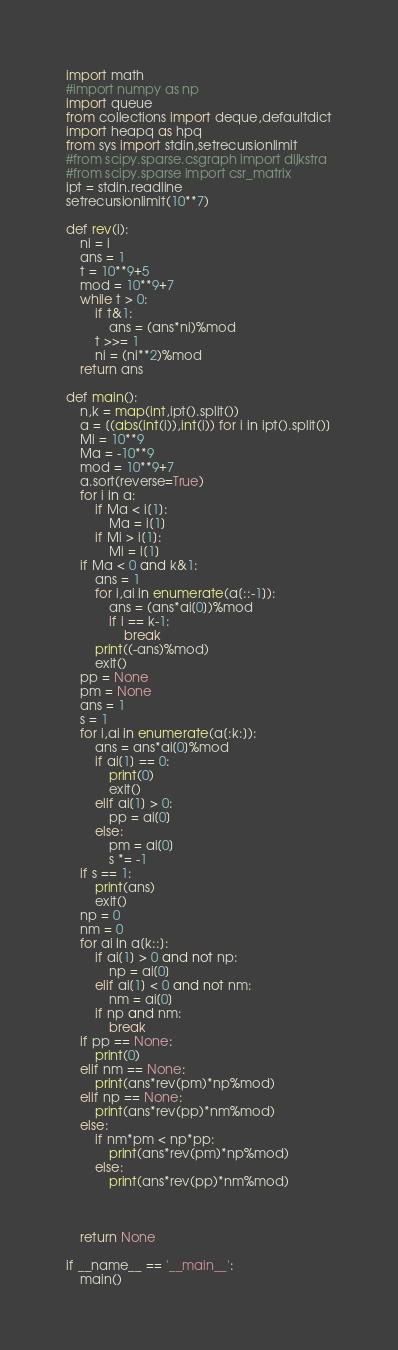<code> <loc_0><loc_0><loc_500><loc_500><_Python_>import math
#import numpy as np
import queue
from collections import deque,defaultdict
import heapq as hpq
from sys import stdin,setrecursionlimit
#from scipy.sparse.csgraph import dijkstra
#from scipy.sparse import csr_matrix
ipt = stdin.readline
setrecursionlimit(10**7)

def rev(i):
    ni = i
    ans = 1
    t = 10**9+5
    mod = 10**9+7
    while t > 0:
        if t&1:
            ans = (ans*ni)%mod
        t >>= 1
        ni = (ni**2)%mod
    return ans

def main():
    n,k = map(int,ipt().split())
    a = [(abs(int(i)),int(i)) for i in ipt().split()]
    Mi = 10**9
    Ma = -10**9
    mod = 10**9+7
    a.sort(reverse=True)
    for i in a:
        if Ma < i[1]:
            Ma = i[1]
        if Mi > i[1]:
            Mi = i[1]
    if Ma < 0 and k&1:
        ans = 1
        for i,ai in enumerate(a[::-1]):
            ans = (ans*ai[0])%mod
            if i == k-1:
                break
        print((-ans)%mod)
        exit()
    pp = None
    pm = None
    ans = 1
    s = 1
    for i,ai in enumerate(a[:k:]):
        ans = ans*ai[0]%mod
        if ai[1] == 0:
            print(0)
            exit()
        elif ai[1] > 0:
            pp = ai[0]
        else:
            pm = ai[0]
            s *= -1
    if s == 1:
        print(ans)
        exit()
    np = 0
    nm = 0
    for ai in a[k::]:
        if ai[1] > 0 and not np:
            np = ai[0]
        elif ai[1] < 0 and not nm:
            nm = ai[0]
        if np and nm:
            break
    if pp == None:
        print(0)
    elif nm == None:
        print(ans*rev(pm)*np%mod)
    elif np == None:
        print(ans*rev(pp)*nm%mod)
    else:
        if nm*pm < np*pp:
            print(ans*rev(pm)*np%mod)
        else:
            print(ans*rev(pp)*nm%mod)



    return None

if __name__ == '__main__':
    main()
</code> 